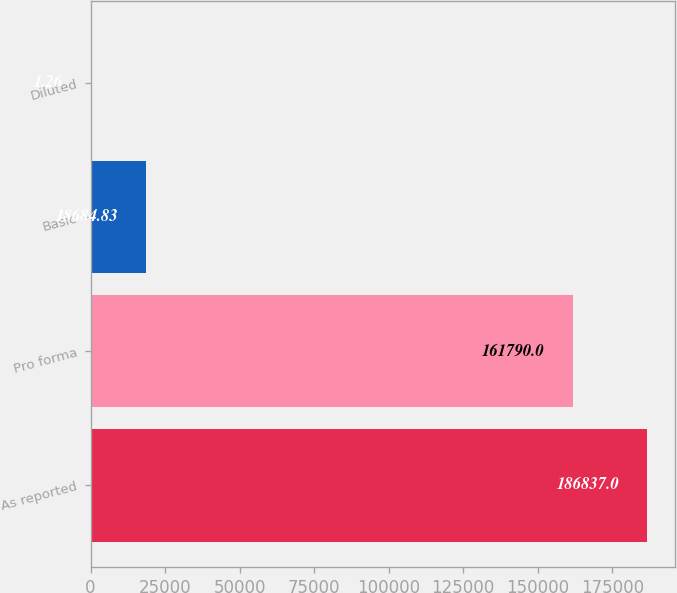<chart> <loc_0><loc_0><loc_500><loc_500><bar_chart><fcel>As reported<fcel>Pro forma<fcel>Basic<fcel>Diluted<nl><fcel>186837<fcel>161790<fcel>18684.8<fcel>1.26<nl></chart> 